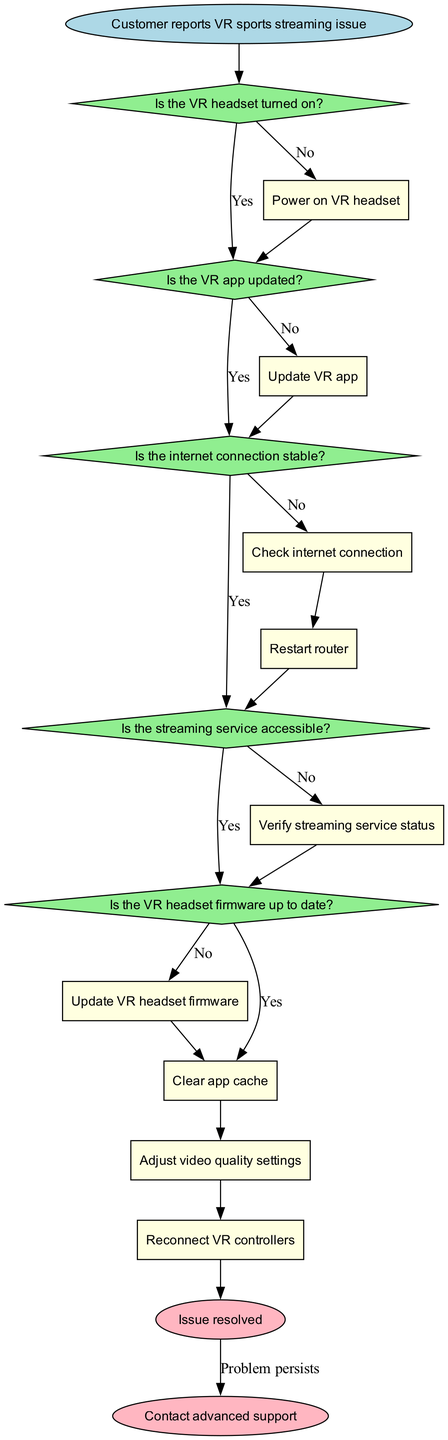What's the starting point of the troubleshooting process? The starting point of the troubleshooting process is the node labeled "Customer reports VR sports streaming issue." This is the first step that initiates the flow chart.
Answer: Customer reports VR sports streaming issue How many decision nodes are in the diagram? The diagram contains five decision nodes: "Is the VR headset turned on?", "Is the VR app updated?", "Is the internet connection stable?", "Is the streaming service accessible?", and "Is the VR headset firmware up to date?" Therefore, counting these, we find there are five decision nodes.
Answer: 5 What action should be taken if the VR headset is not turned on? If the VR headset is not turned on, the action specified in the diagram is to "Power on VR headset." This action directly follows from the decision indicating that the headset is off.
Answer: Power on VR headset If the internet connection is unstable, which action is next? If the internet connection is identified as unstable, the next action is to "Restart router." This follows the decision that confirms the internet connection is not stable, leading to this particular action.
Answer: Restart router What is the last action before the issue is resolved? The last action before reaching the end node indicating "Issue resolved" is "Adjust video quality settings." This step is the final action that leads directly to resolving the streaming issue.
Answer: Adjust video quality settings What happens if the problem persists after attempting all actions? If the problem persists after attempting all prescribed actions, the flow chart leads to the end node labeled "Contact advanced support." This indicates that the issue could not be resolved through standard troubleshooting steps.
Answer: Contact advanced support What is the relationship between the "Is the VR app updated?" and "Is the internet connection stable?" nodes? The relationship is sequential; if the VR app is updated (Yes), we move to check the internet connection stability. If the app is not updated (No), we take the action "Update VR app" before checking the internet connection. Thus, they are connected within the flow of troubleshooting.
Answer: Sequential 